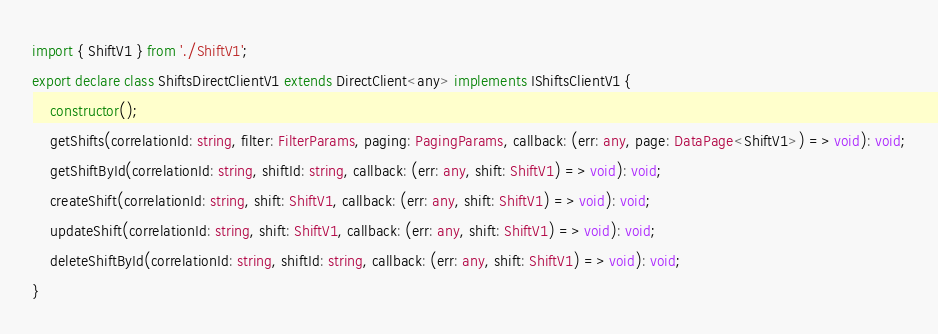Convert code to text. <code><loc_0><loc_0><loc_500><loc_500><_TypeScript_>import { ShiftV1 } from './ShiftV1';
export declare class ShiftsDirectClientV1 extends DirectClient<any> implements IShiftsClientV1 {
    constructor();
    getShifts(correlationId: string, filter: FilterParams, paging: PagingParams, callback: (err: any, page: DataPage<ShiftV1>) => void): void;
    getShiftById(correlationId: string, shiftId: string, callback: (err: any, shift: ShiftV1) => void): void;
    createShift(correlationId: string, shift: ShiftV1, callback: (err: any, shift: ShiftV1) => void): void;
    updateShift(correlationId: string, shift: ShiftV1, callback: (err: any, shift: ShiftV1) => void): void;
    deleteShiftById(correlationId: string, shiftId: string, callback: (err: any, shift: ShiftV1) => void): void;
}
</code> 